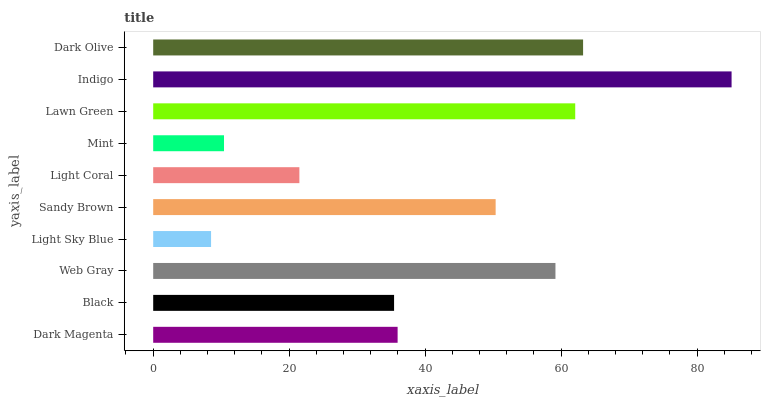Is Light Sky Blue the minimum?
Answer yes or no. Yes. Is Indigo the maximum?
Answer yes or no. Yes. Is Black the minimum?
Answer yes or no. No. Is Black the maximum?
Answer yes or no. No. Is Dark Magenta greater than Black?
Answer yes or no. Yes. Is Black less than Dark Magenta?
Answer yes or no. Yes. Is Black greater than Dark Magenta?
Answer yes or no. No. Is Dark Magenta less than Black?
Answer yes or no. No. Is Sandy Brown the high median?
Answer yes or no. Yes. Is Dark Magenta the low median?
Answer yes or no. Yes. Is Dark Magenta the high median?
Answer yes or no. No. Is Light Coral the low median?
Answer yes or no. No. 